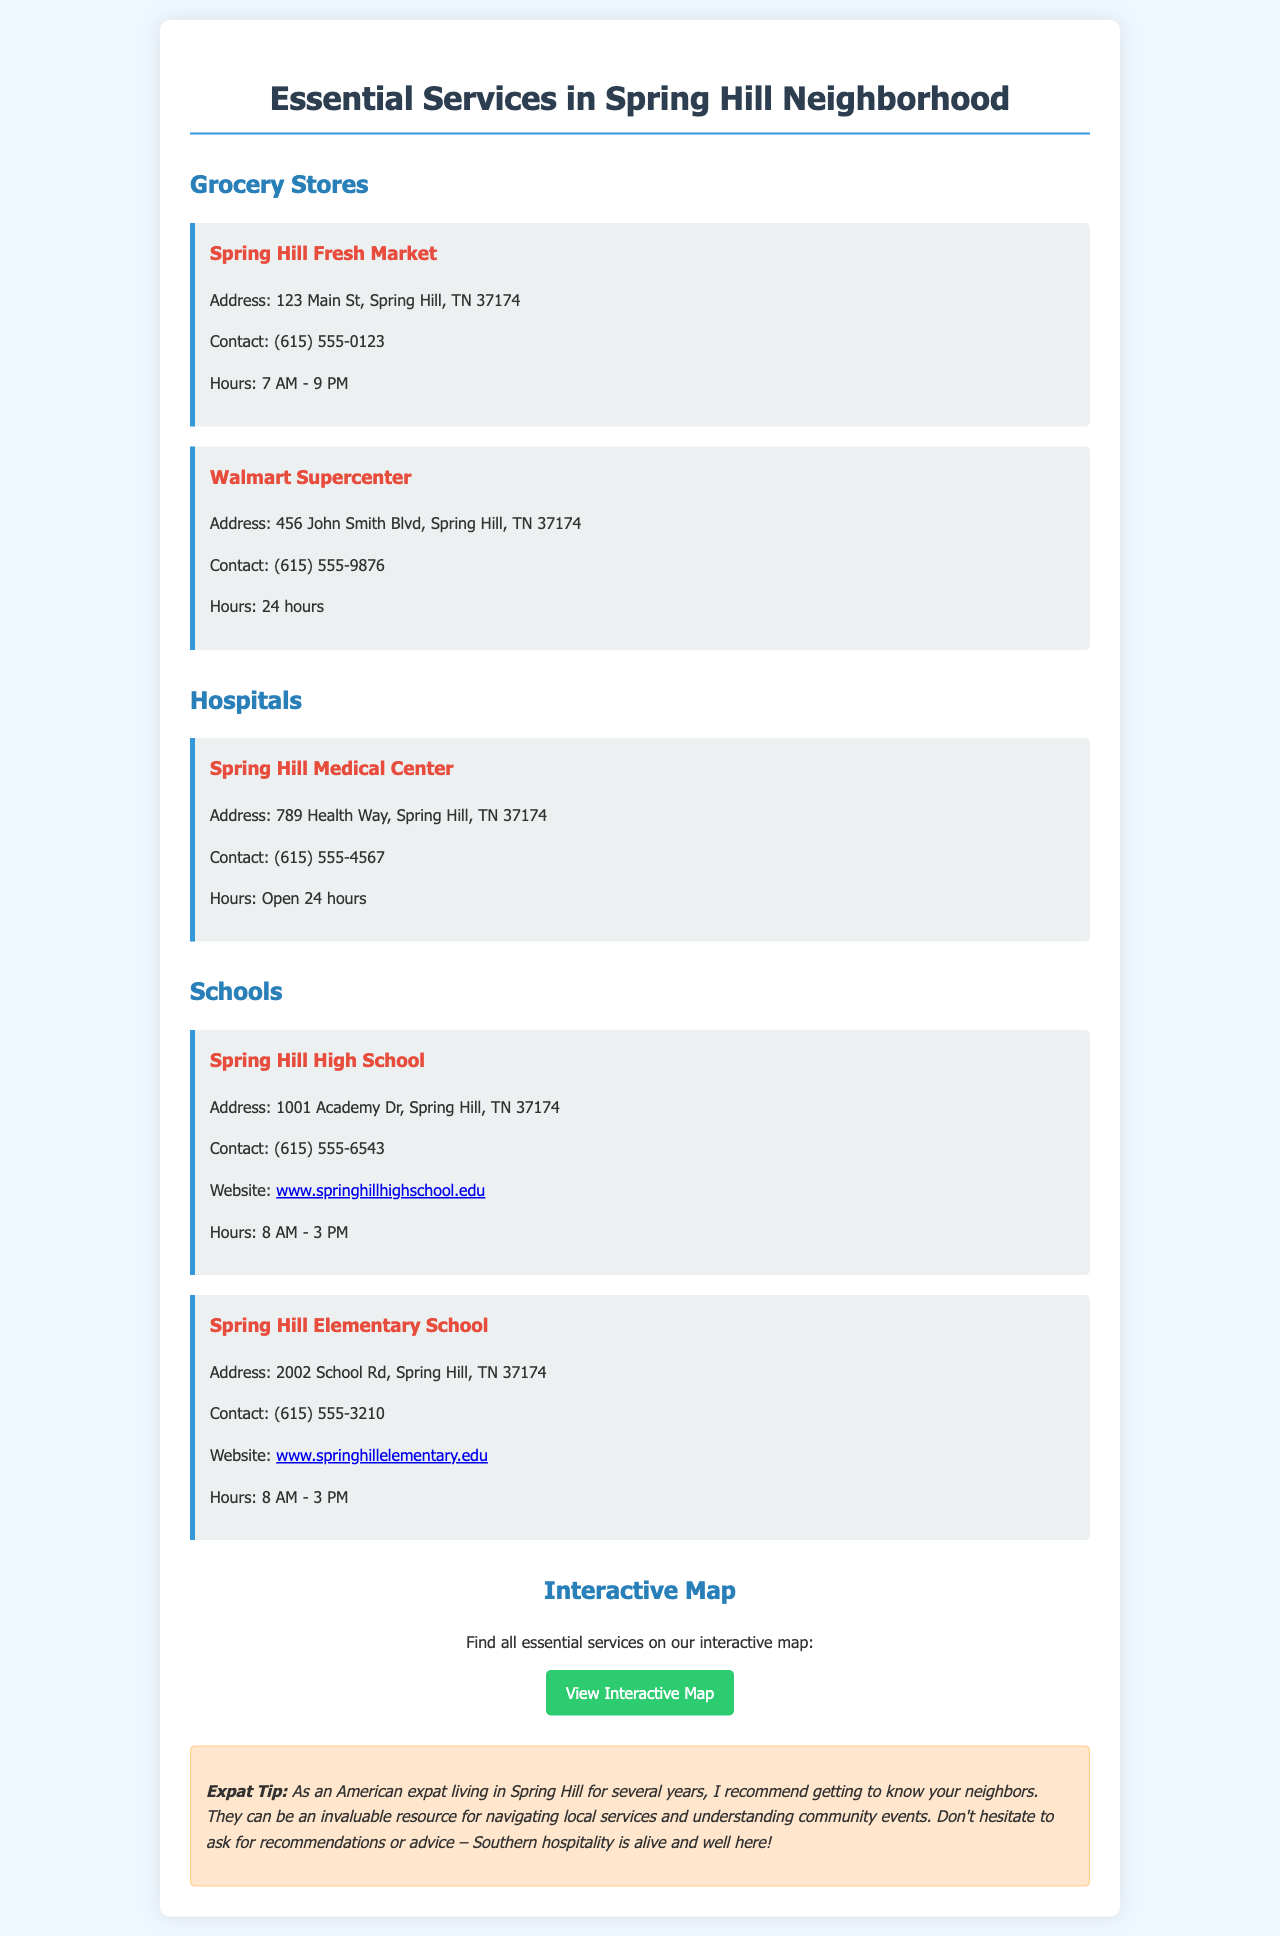What is the address of Spring Hill Fresh Market? The address is explicitly stated in the grocery store section of the document.
Answer: 123 Main St, Spring Hill, TN 37174 What are the hours for Walmart Supercenter? The hours of operation are provided in the grocery store section.
Answer: 24 hours What is the contact number for Spring Hill Medical Center? The contact information is listed in the hospital section of the document.
Answer: (615) 555-4567 Which two schools are mentioned in the guide? The schools section contains the names of the two schools listed.
Answer: Spring Hill High School and Spring Hill Elementary School What is the website for Spring Hill Elementary School? The website is explicitly mentioned under the Spring Hill Elementary School section.
Answer: www.springhillelementary.edu How is the neighborhood described by the expat tip? The expat tip provides insight into the local culture and suggests engaging with neighbors.
Answer: Southern hospitality What type of interactive feature is included in the document? The document mentions an interactive map for locating essential services.
Answer: Interactive map What is the color of the section headers in the document? The colors used for headings can be inferred from the design style in the document.
Answer: Blue 